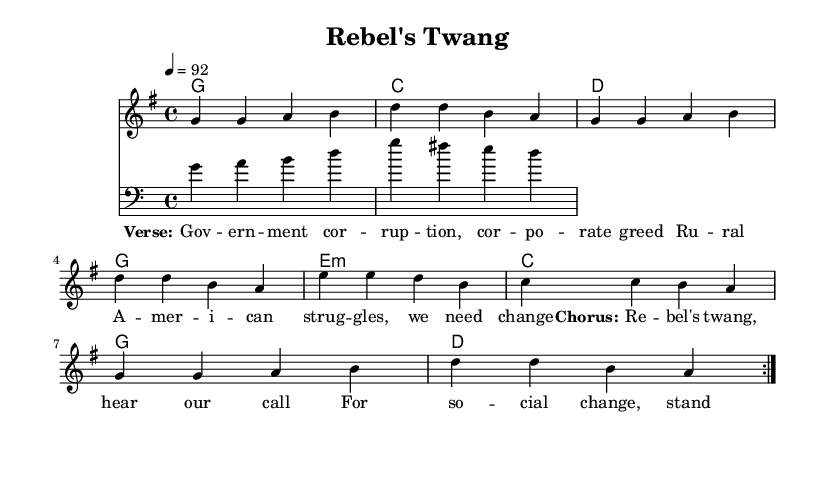What is the key signature of this music? The key signature is G major, which has one sharp. In the `global` block, it defines the key signature with `\key g \major`.
Answer: G major What is the time signature of this music? The time signature is 4/4, which is indicated in the `global` block with `\time 4/4`. This means there are four beats per measure.
Answer: 4/4 What is the tempo marking of this composition? The tempo marking is 92 beats per minute, as noted by the `\tempo 4 = 92` directive in the `global` block.
Answer: 92 How many measures are in the melody section? The melody section contains 8 measures, as seen in the repeated structure and divisions of the `melody`. Each measure is separated by vertical lines.
Answer: 8 measures What are the first three words of the lyrics? The first three words of the lyrics are "Gov -- ern -- ment", as extracted from the `\lyricsto` section, which lists the lyrics corresponding to the melody.
Answer: Gov -- ern -- ment Does this piece incorporate both rap and country elements? Yes, the piece combines rap's politically charged themes with a rebellious country-rock edge in its overall style and lyrical content, as indicated by the song title and the lyrics' themes.
Answer: Yes What chord is played during the chorus? The chord played during the chorus is G major, as seen in the `\chordmode` where "g" appears in the configuration for the repeated sections.
Answer: G major 